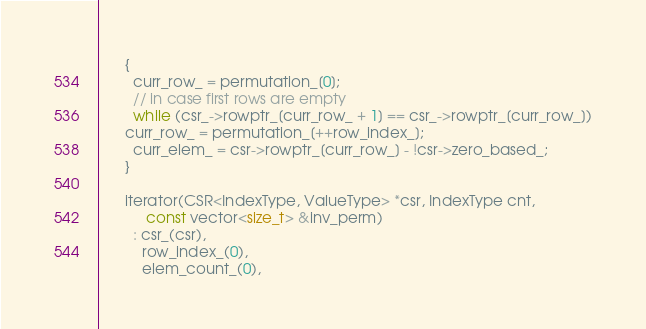Convert code to text. <code><loc_0><loc_0><loc_500><loc_500><_C++_>      {
        curr_row_ = permutation_[0];
        // in case first rows are empty
        while (csr_->rowptr_[curr_row_ + 1] == csr_->rowptr_[curr_row_])
	  curr_row_ = permutation_[++row_index_];
        curr_elem_ = csr->rowptr_[curr_row_] - !csr->zero_based_;
      }

      iterator(CSR<IndexType, ValueType> *csr, IndexType cnt,
	       const vector<size_t> &inv_perm)
        : csr_(csr),
          row_index_(0),
          elem_count_(0),</code> 